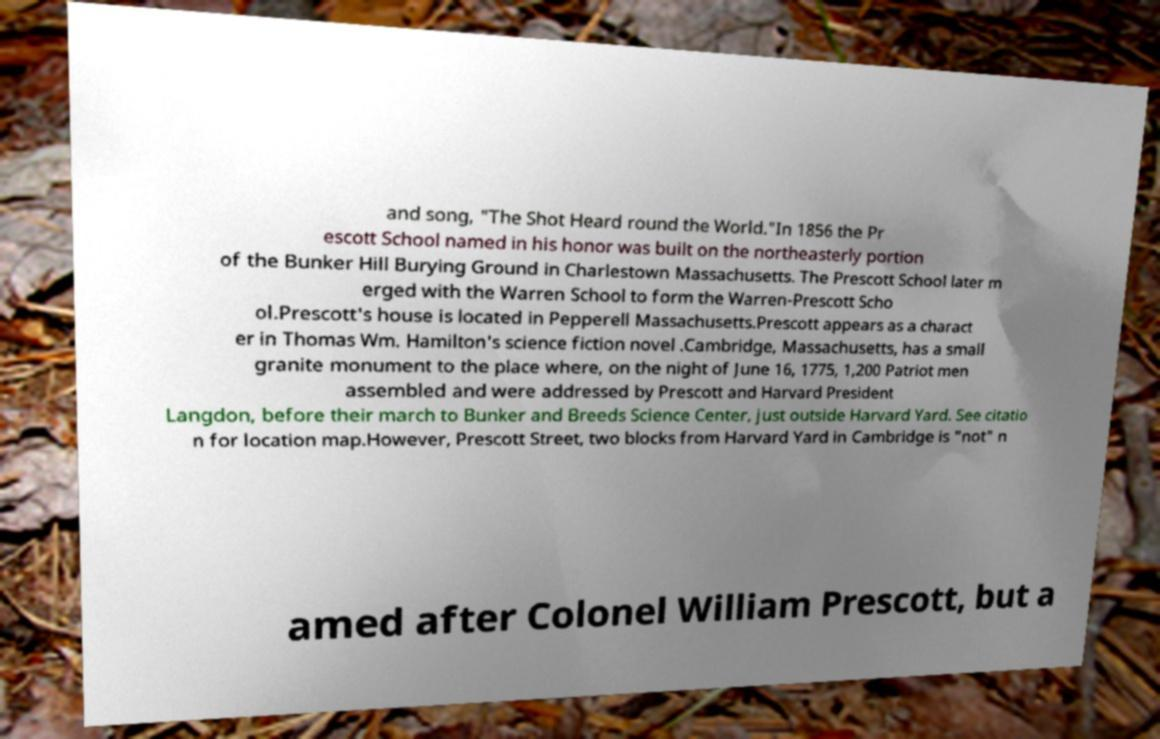What messages or text are displayed in this image? I need them in a readable, typed format. and song, "The Shot Heard round the World."In 1856 the Pr escott School named in his honor was built on the northeasterly portion of the Bunker Hill Burying Ground in Charlestown Massachusetts. The Prescott School later m erged with the Warren School to form the Warren-Prescott Scho ol.Prescott's house is located in Pepperell Massachusetts.Prescott appears as a charact er in Thomas Wm. Hamilton's science fiction novel .Cambridge, Massachusetts, has a small granite monument to the place where, on the night of June 16, 1775, 1,200 Patriot men assembled and were addressed by Prescott and Harvard President Langdon, before their march to Bunker and Breeds Science Center, just outside Harvard Yard. See citatio n for location map.However, Prescott Street, two blocks from Harvard Yard in Cambridge is "not" n amed after Colonel William Prescott, but a 